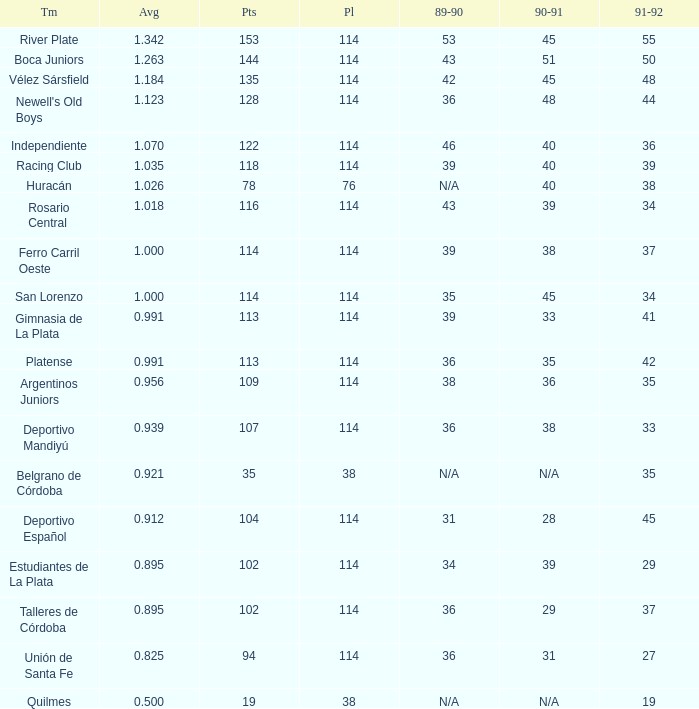How much 1991-1992 has a Team of gimnasia de la plata, and more than 113 points? 0.0. 